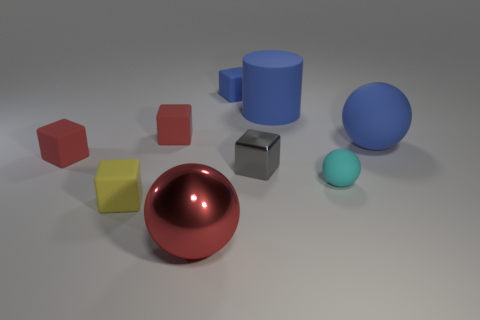Which objects in the image could feasibly float on water? Considering their appearance, the blue rubber cylinder and the small blue ball seem like objects that could potentially float on water due to their materials and shapes typically associated with buoyancy. 